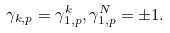<formula> <loc_0><loc_0><loc_500><loc_500>\gamma _ { k , p } = \gamma _ { 1 , p } ^ { k } , \gamma _ { 1 , p } ^ { N } = \pm 1 .</formula> 